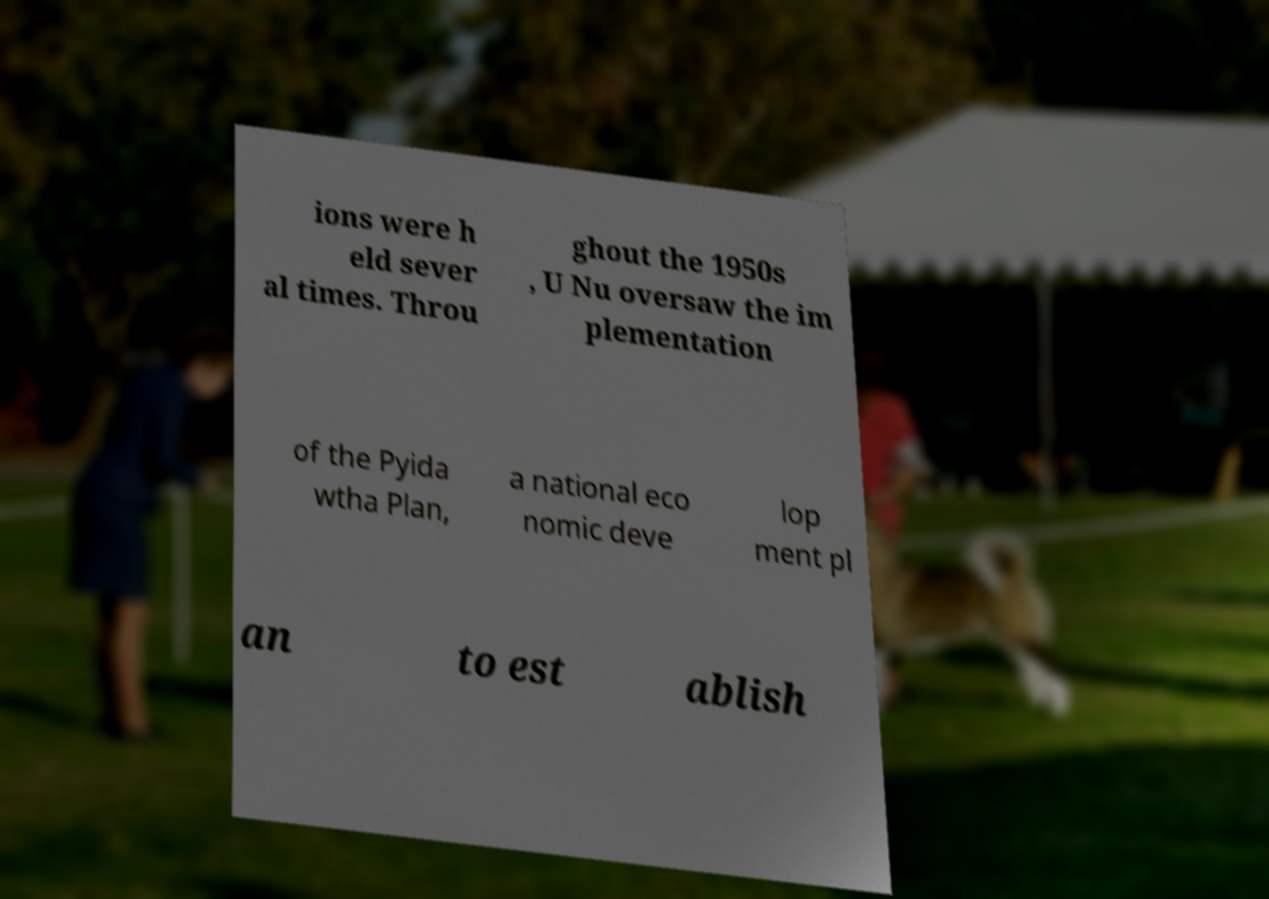Can you read and provide the text displayed in the image?This photo seems to have some interesting text. Can you extract and type it out for me? ions were h eld sever al times. Throu ghout the 1950s , U Nu oversaw the im plementation of the Pyida wtha Plan, a national eco nomic deve lop ment pl an to est ablish 